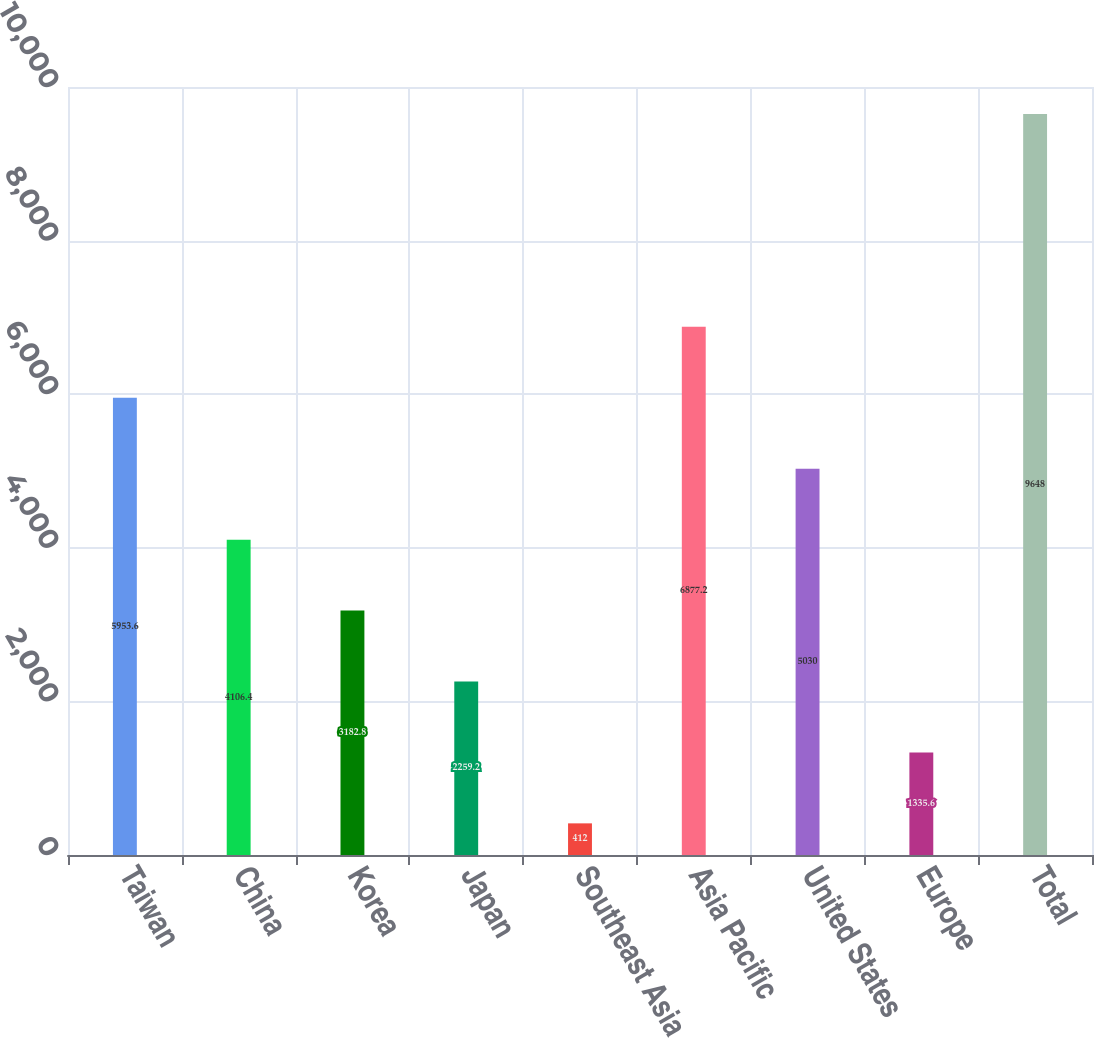Convert chart to OTSL. <chart><loc_0><loc_0><loc_500><loc_500><bar_chart><fcel>Taiwan<fcel>China<fcel>Korea<fcel>Japan<fcel>Southeast Asia<fcel>Asia Pacific<fcel>United States<fcel>Europe<fcel>Total<nl><fcel>5953.6<fcel>4106.4<fcel>3182.8<fcel>2259.2<fcel>412<fcel>6877.2<fcel>5030<fcel>1335.6<fcel>9648<nl></chart> 